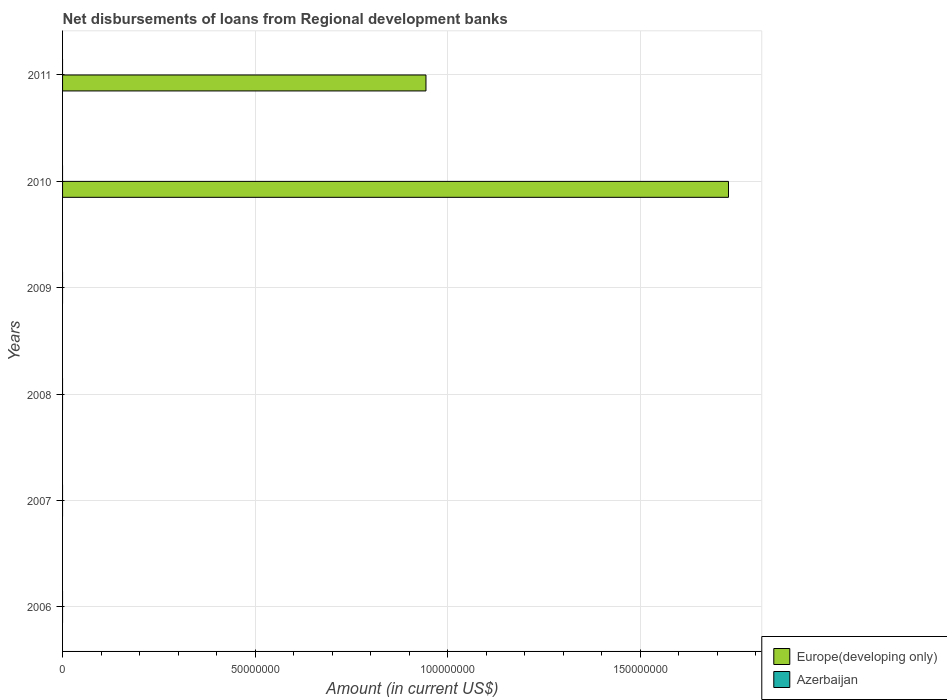Are the number of bars on each tick of the Y-axis equal?
Ensure brevity in your answer.  No. How many bars are there on the 5th tick from the top?
Provide a succinct answer. 0. How many bars are there on the 1st tick from the bottom?
Keep it short and to the point. 0. In how many cases, is the number of bars for a given year not equal to the number of legend labels?
Your answer should be compact. 6. What is the amount of disbursements of loans from regional development banks in Azerbaijan in 2008?
Provide a succinct answer. 0. Across all years, what is the maximum amount of disbursements of loans from regional development banks in Europe(developing only)?
Offer a terse response. 1.73e+08. In which year was the amount of disbursements of loans from regional development banks in Europe(developing only) maximum?
Give a very brief answer. 2010. What is the total amount of disbursements of loans from regional development banks in Europe(developing only) in the graph?
Provide a succinct answer. 2.67e+08. What is the difference between the amount of disbursements of loans from regional development banks in Europe(developing only) in 2010 and that in 2011?
Provide a short and direct response. 7.85e+07. What is the average amount of disbursements of loans from regional development banks in Azerbaijan per year?
Give a very brief answer. 0. What is the difference between the highest and the lowest amount of disbursements of loans from regional development banks in Europe(developing only)?
Give a very brief answer. 1.73e+08. How many years are there in the graph?
Provide a succinct answer. 6. What is the difference between two consecutive major ticks on the X-axis?
Make the answer very short. 5.00e+07. Are the values on the major ticks of X-axis written in scientific E-notation?
Give a very brief answer. No. How are the legend labels stacked?
Offer a very short reply. Vertical. What is the title of the graph?
Keep it short and to the point. Net disbursements of loans from Regional development banks. What is the label or title of the X-axis?
Offer a terse response. Amount (in current US$). What is the Amount (in current US$) of Europe(developing only) in 2006?
Your response must be concise. 0. What is the Amount (in current US$) of Europe(developing only) in 2007?
Make the answer very short. 0. What is the Amount (in current US$) in Azerbaijan in 2008?
Your answer should be very brief. 0. What is the Amount (in current US$) in Europe(developing only) in 2009?
Your answer should be compact. 0. What is the Amount (in current US$) of Azerbaijan in 2009?
Give a very brief answer. 0. What is the Amount (in current US$) of Europe(developing only) in 2010?
Ensure brevity in your answer.  1.73e+08. What is the Amount (in current US$) in Azerbaijan in 2010?
Your response must be concise. 0. What is the Amount (in current US$) of Europe(developing only) in 2011?
Provide a short and direct response. 9.43e+07. What is the Amount (in current US$) in Azerbaijan in 2011?
Your answer should be compact. 0. Across all years, what is the maximum Amount (in current US$) of Europe(developing only)?
Give a very brief answer. 1.73e+08. What is the total Amount (in current US$) in Europe(developing only) in the graph?
Make the answer very short. 2.67e+08. What is the difference between the Amount (in current US$) in Europe(developing only) in 2010 and that in 2011?
Your response must be concise. 7.85e+07. What is the average Amount (in current US$) of Europe(developing only) per year?
Offer a very short reply. 4.45e+07. What is the ratio of the Amount (in current US$) of Europe(developing only) in 2010 to that in 2011?
Ensure brevity in your answer.  1.83. What is the difference between the highest and the lowest Amount (in current US$) of Europe(developing only)?
Offer a terse response. 1.73e+08. 